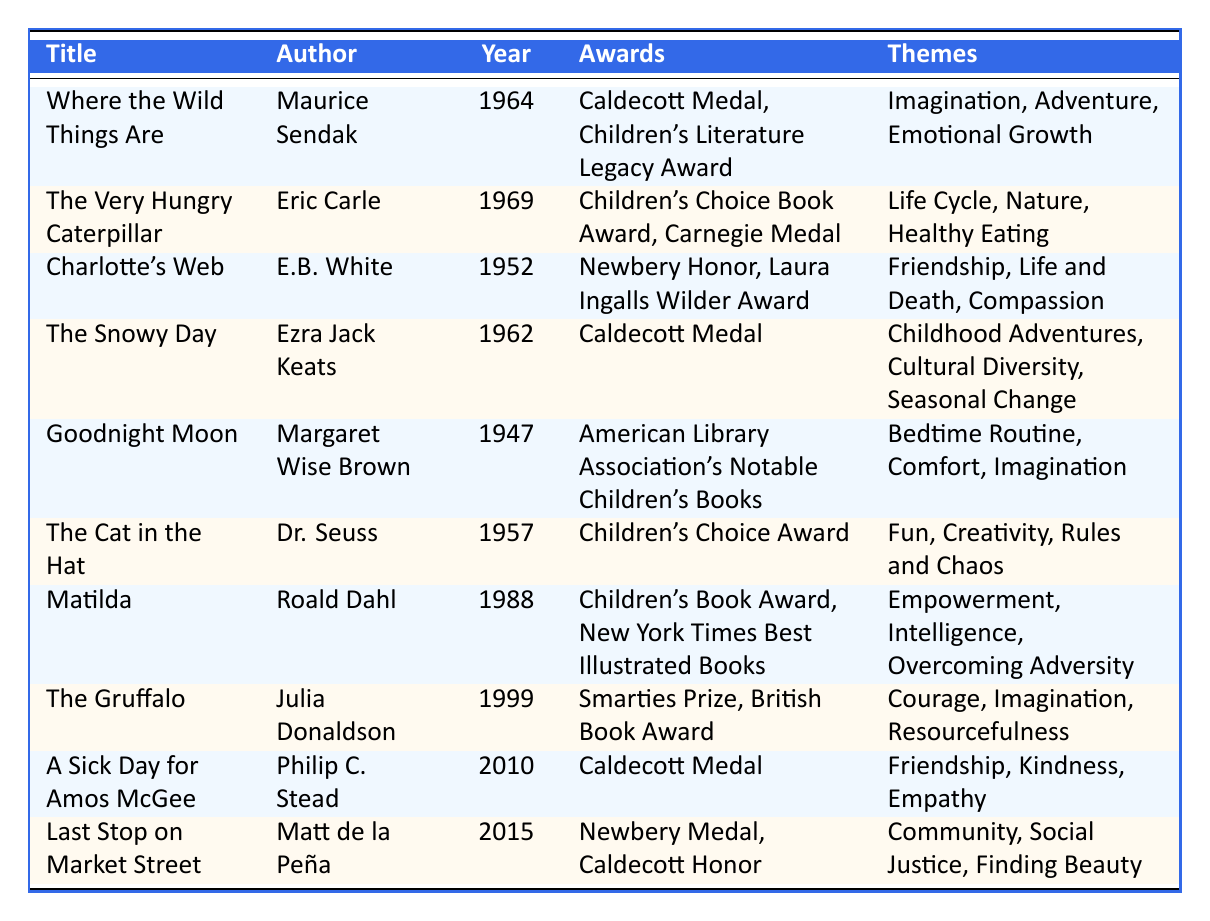What is the theme of "Charlotte's Web"? The table lists "Friendship," "Life and Death," and "Compassion" as the themes associated with "Charlotte's Web."
Answer: Friendship, Life and Death, Compassion Which author wrote "The Very Hungry Caterpillar"? By checking the table, it shows that "The Very Hungry Caterpillar" was written by Eric Carle.
Answer: Eric Carle How many awards did "Matilda" receive? The table indicates that "Matilda" received two awards: "Children's Book Award" and "New York Times Best Illustrated Books."
Answer: 2 List one theme from the book "The Gruffalo." According to the table, one of the themes from "The Gruffalo" is "Courage."
Answer: Courage Is "The Cat in the Hat" the oldest book on the list? The table details the publication year of "The Cat in the Hat" as 1957, and the oldest book is "Goodnight Moon," published in 1947. Thus, it is not the oldest.
Answer: No Which book was awarded the Caldecott Medal in 2010? The table shows that "A Sick Day for Amos McGee" is the book that was awarded the Caldecott Medal in 2010.
Answer: A Sick Day for Amos McGee What are the themes for "Last Stop on Market Street"? The table lists "Community," "Social Justice," and "Finding Beauty" as the themes for "Last Stop on Market Street."
Answer: Community, Social Justice, Finding Beauty Which book won the Newbery Medal and was published after 2000? The table indicates that "Last Stop on Market Street," published in 2015, won the Newbery Medal.
Answer: Last Stop on Market Street How many books in the table have the theme of "Imagination"? By reviewing the themes listed, "Where the Wild Things Are," "Goodnight Moon," "The Cat in the Hat," and "The Gruffalo" all have "Imagination" as a theme, making it a total of four books.
Answer: 4 Which themes are shared between "A Sick Day for Amos McGee" and "Charlotte's Web"? Looking through the themes, both "Empathy" in "A Sick Day for Amos McGee" and "Compassion" in "Charlotte's Web" relate to caring for others, but only "Friendship" is explicitly shared.
Answer: Friendship If you add the years of publication for "The Snowy Day" and "The Gruffalo," what is the total? "The Snowy Day" was published in 1962 and "The Gruffalo" in 1999. Adding these two years together gives: 1962 + 1999 = 3961.
Answer: 3961 